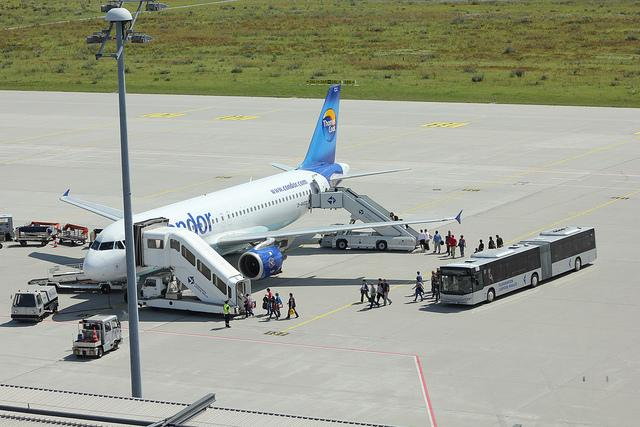What is the name of the blue piece on the end of the plane? tail 